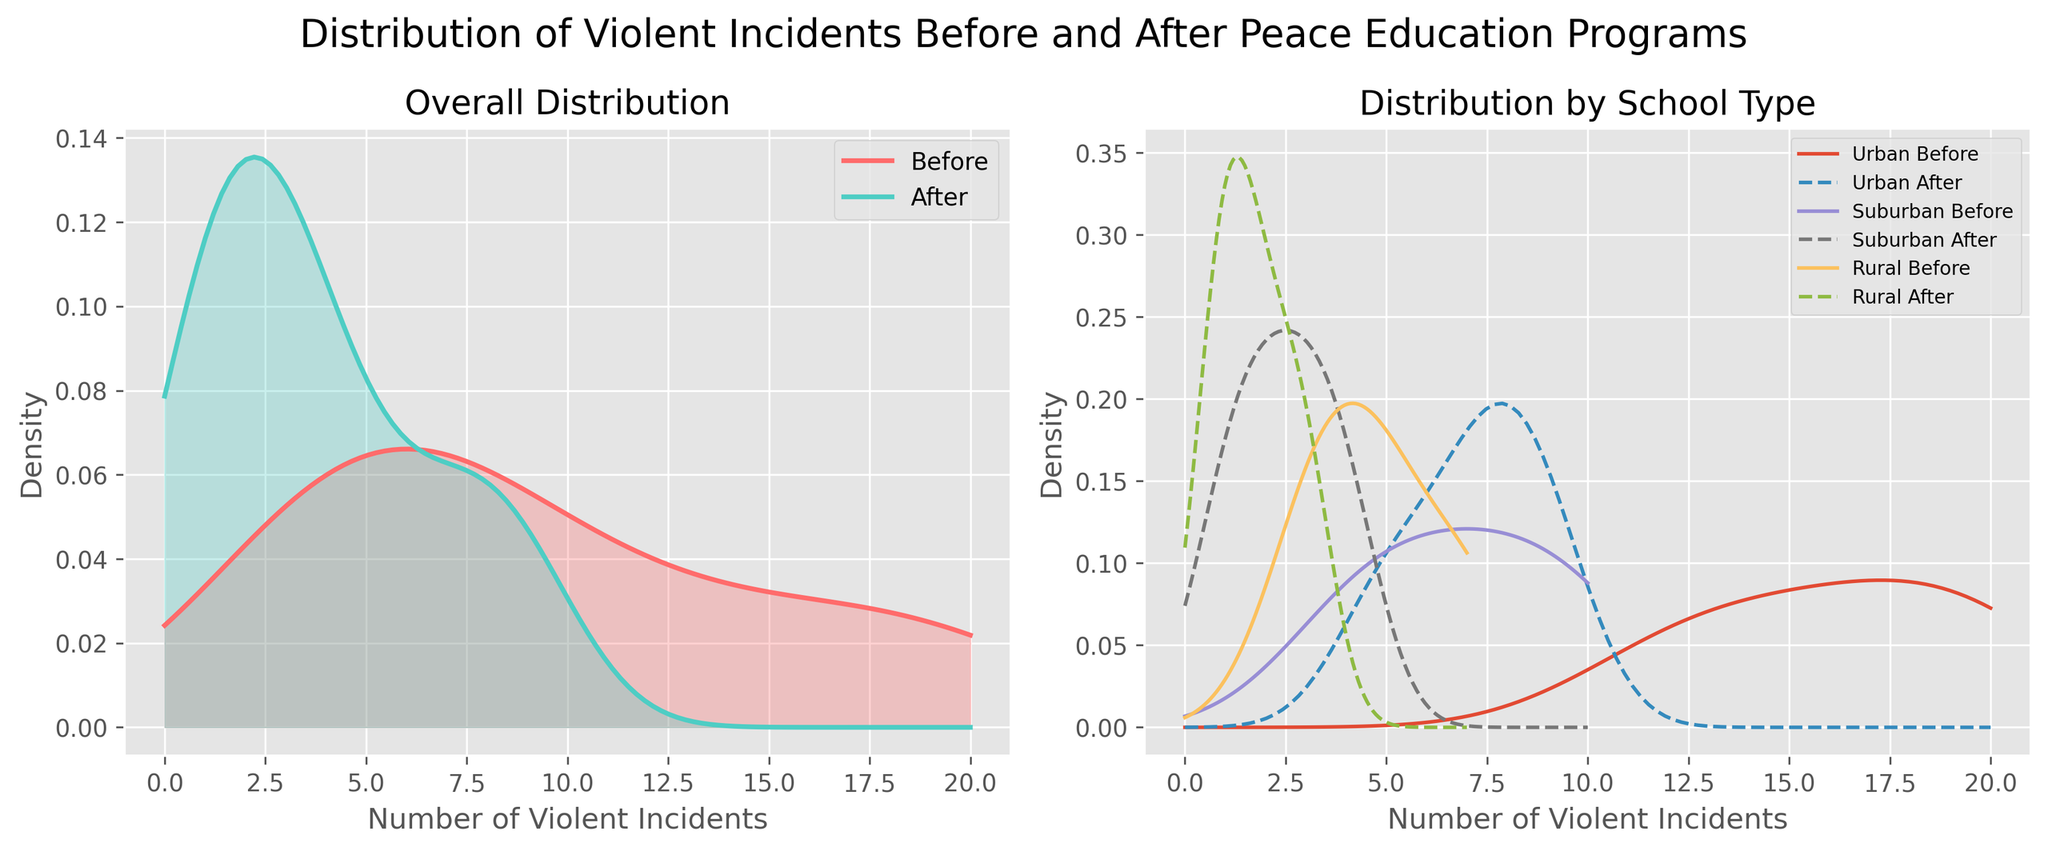How many types of schools are represented in the figure? By looking at the plots in the subplot for 'Distribution by School Type,' we can see three different line patterns representing Urban, Suburban, and Rural schools.
Answer: Three What is the title of the figure? The title is displayed at the top of the figure. It reads: 'Distribution of Violent Incidents Before and After Peace Education Programs.'
Answer: Distribution of Violent Incidents Before and After Peace Education Programs Which line color represents the BEFORE peace education programs incidences in the 'Overall Distribution' subplot? The line representing the before incidences in the 'Overall Distribution' has a color described by the legend as '#FF6B6B'.
Answer: Red Which school type shows the most significant reduction in violent incidents after peace education programs in the 'Distribution by School Type' subplot? In the subplot for 'Distribution by School Type,' we see the largest gap between 'Before' and 'After' lines for Urban schools, indicating a more significant reduction.
Answer: Urban What does the x-axis represent in both subplots? The x-axis in both subplots is labeled 'Number of Violent Incidents,' indicating that it represents the number of violent incidents reported.
Answer: Number of Violent Incidents Which density plot in the 'Overall Distribution' subplot is filled with a translucent blue shade? The filled density plot with a translucent blue shade represents the distribution of violent incidents after peace education programs, as per the legend.
Answer: After On the 'Distribution by School Type' subplot, how is the 'Before' distribution line of Suburban schools visually differentiated from the 'After' distribution line? The 'Before' distribution line for Suburban schools is a solid line, while the 'After' line is a dashed one.
Answer: By line style What can be inferred about the impact of peace education programs on overall violent incidents based on the 'Overall Distribution' subplot? Since the density plot for 'After' has shifted leftwards and is lower compared to 'Before,' it implies that the average number of violent incidents has decreased due to peace education programs.
Answer: Decrease in incidents How does the distribution of violent incidents in Rural schools before the peace education programs compare to after, based on the 'Distribution by School Type' subplot? The 'Before' line for Rural schools is higher and shifts rightwards compared to the 'After' line, indicating more incidents before the programs.
Answer: Fewer incidents after 